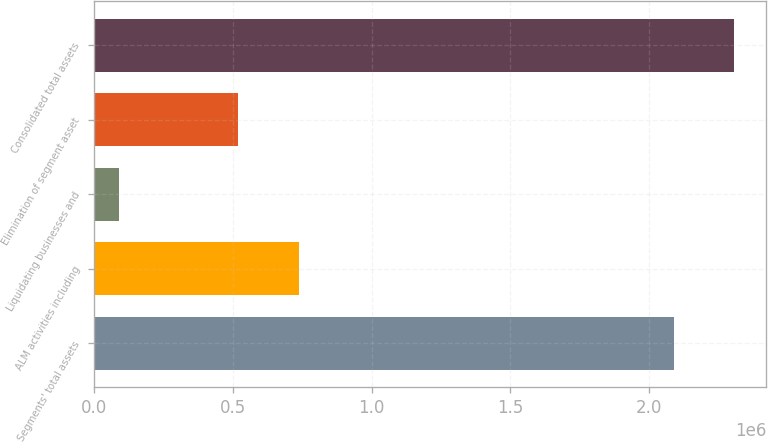<chart> <loc_0><loc_0><loc_500><loc_500><bar_chart><fcel>Segments' total assets<fcel>ALM activities including<fcel>Liquidating businesses and<fcel>Elimination of segment asset<fcel>Consolidated total assets<nl><fcel>2.08719e+06<fcel>739671<fcel>89008<fcel>520448<fcel>2.30641e+06<nl></chart> 